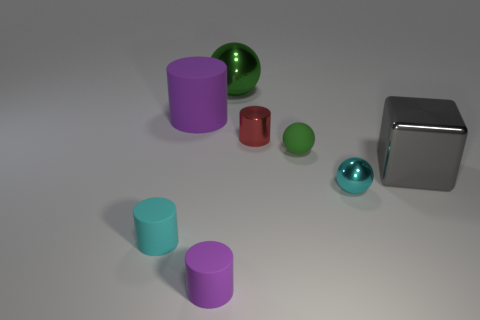How many objects are either purple matte cylinders that are on the left side of the cyan ball or spheres that are in front of the large metal cube?
Ensure brevity in your answer.  3. There is a large metallic thing behind the tiny shiny cylinder to the left of the cyan metal thing; what color is it?
Provide a short and direct response. Green. There is another large ball that is the same material as the cyan ball; what color is it?
Keep it short and to the point. Green. What number of other cylinders are the same color as the large cylinder?
Provide a succinct answer. 1. What number of things are either green objects or purple shiny things?
Make the answer very short. 2. There is a metallic thing that is the same size as the metallic cube; what is its shape?
Your answer should be compact. Sphere. What number of tiny cylinders are both behind the tiny green rubber object and to the left of the big metal sphere?
Give a very brief answer. 0. What material is the tiny cylinder that is behind the cyan shiny ball?
Your answer should be very brief. Metal. The green sphere that is the same material as the tiny cyan sphere is what size?
Your response must be concise. Large. Is the size of the cyan object to the right of the large cylinder the same as the purple cylinder that is behind the rubber ball?
Make the answer very short. No. 